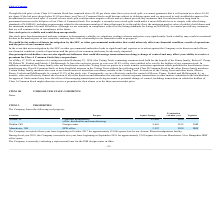According to Westell Technologies's financial document, When was the start of the lease of the headquarters facility? According to the financial document, October 2017. The relevant text states: "Company executed a three-year lease beginning in October 2017 for approximately 83,000 square feet for our Aurora, Illinois headquarters facility...." Also, What is the square footage of the real property in Aurora, IL? According to the financial document, 83,000. The relevant text states: "83,000..." Also, What is the result of the Kentrox acquisition? Based on the financial document, the answer is the Company acquired a sixteen acre parcel of land in Dublin, Ohio. Additionally, Which location has the biggest square footage?  According to the financial document, Aurora, IL. The relevant text states: "Aurora, IL..." Also, can you calculate: What is the total area, in square feet, of the Company’s real property? Based on the calculation: 83,000+9,465+2,287 , the result is 94752. This is based on the information: "Manchester, NH IBW office 2,287 2020 IBW 83,000 Dublin, OH Design center 9,465 2019 ISM..." The key data points involved are: 2,287, 83,000, 9,465. Additionally, Which location has the earliest termination year of its lease? According to the financial document, Dublin, OH. The relevant text states: "Dublin, OH Design center 9,465 2019 ISM..." 